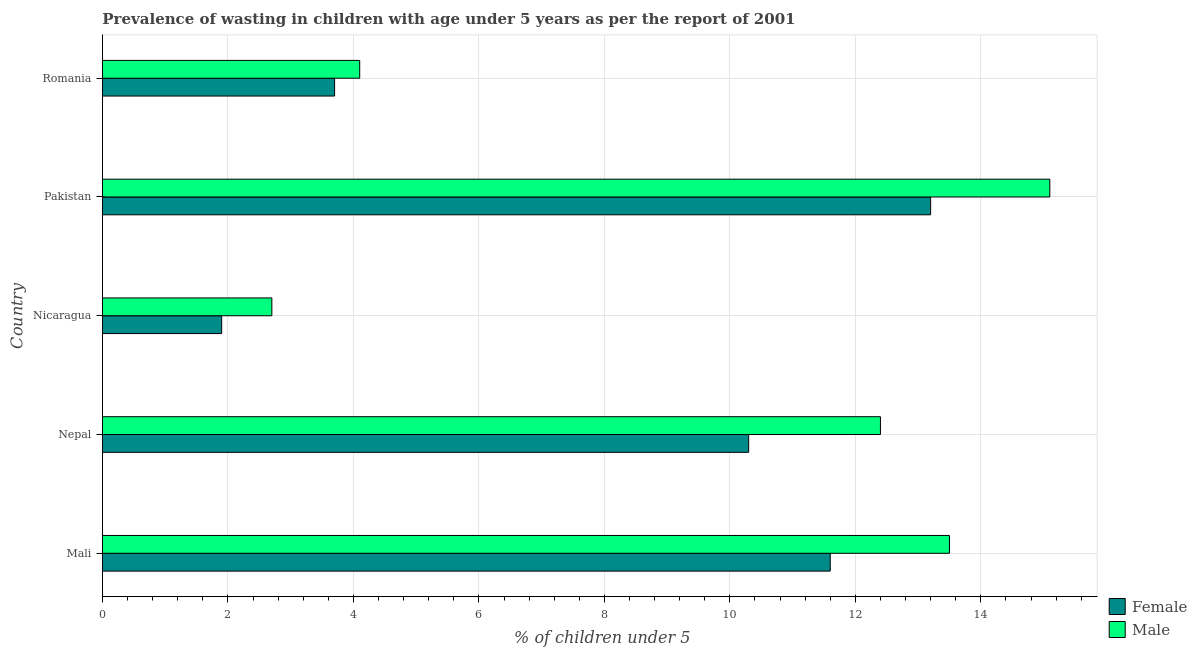Are the number of bars per tick equal to the number of legend labels?
Your answer should be compact. Yes. Are the number of bars on each tick of the Y-axis equal?
Offer a very short reply. Yes. How many bars are there on the 2nd tick from the top?
Provide a short and direct response. 2. How many bars are there on the 4th tick from the bottom?
Your response must be concise. 2. What is the label of the 5th group of bars from the top?
Give a very brief answer. Mali. In how many cases, is the number of bars for a given country not equal to the number of legend labels?
Your response must be concise. 0. What is the percentage of undernourished male children in Mali?
Your response must be concise. 13.5. Across all countries, what is the maximum percentage of undernourished male children?
Give a very brief answer. 15.1. Across all countries, what is the minimum percentage of undernourished male children?
Your answer should be compact. 2.7. In which country was the percentage of undernourished male children minimum?
Your answer should be very brief. Nicaragua. What is the total percentage of undernourished female children in the graph?
Give a very brief answer. 40.7. What is the difference between the percentage of undernourished male children in Nepal and that in Pakistan?
Ensure brevity in your answer.  -2.7. What is the difference between the percentage of undernourished male children in Mali and the percentage of undernourished female children in Romania?
Your answer should be compact. 9.8. What is the average percentage of undernourished male children per country?
Give a very brief answer. 9.56. What is the ratio of the percentage of undernourished female children in Mali to that in Nepal?
Provide a succinct answer. 1.13. Is the difference between the percentage of undernourished female children in Nepal and Nicaragua greater than the difference between the percentage of undernourished male children in Nepal and Nicaragua?
Offer a very short reply. No. What is the difference between the highest and the second highest percentage of undernourished male children?
Your answer should be compact. 1.6. Is the sum of the percentage of undernourished male children in Pakistan and Romania greater than the maximum percentage of undernourished female children across all countries?
Provide a succinct answer. Yes. What does the 1st bar from the bottom in Mali represents?
Ensure brevity in your answer.  Female. How many bars are there?
Give a very brief answer. 10. Are all the bars in the graph horizontal?
Provide a succinct answer. Yes. What is the difference between two consecutive major ticks on the X-axis?
Keep it short and to the point. 2. Does the graph contain grids?
Offer a very short reply. Yes. Where does the legend appear in the graph?
Give a very brief answer. Bottom right. What is the title of the graph?
Provide a short and direct response. Prevalence of wasting in children with age under 5 years as per the report of 2001. Does "Diarrhea" appear as one of the legend labels in the graph?
Keep it short and to the point. No. What is the label or title of the X-axis?
Your answer should be compact.  % of children under 5. What is the  % of children under 5 in Female in Mali?
Make the answer very short. 11.6. What is the  % of children under 5 of Female in Nepal?
Your answer should be very brief. 10.3. What is the  % of children under 5 in Male in Nepal?
Ensure brevity in your answer.  12.4. What is the  % of children under 5 in Female in Nicaragua?
Your answer should be compact. 1.9. What is the  % of children under 5 of Male in Nicaragua?
Your answer should be very brief. 2.7. What is the  % of children under 5 of Female in Pakistan?
Offer a very short reply. 13.2. What is the  % of children under 5 in Male in Pakistan?
Offer a very short reply. 15.1. What is the  % of children under 5 in Female in Romania?
Offer a terse response. 3.7. What is the  % of children under 5 in Male in Romania?
Keep it short and to the point. 4.1. Across all countries, what is the maximum  % of children under 5 in Female?
Provide a short and direct response. 13.2. Across all countries, what is the maximum  % of children under 5 of Male?
Offer a terse response. 15.1. Across all countries, what is the minimum  % of children under 5 in Female?
Make the answer very short. 1.9. Across all countries, what is the minimum  % of children under 5 in Male?
Offer a very short reply. 2.7. What is the total  % of children under 5 in Female in the graph?
Your answer should be compact. 40.7. What is the total  % of children under 5 of Male in the graph?
Offer a terse response. 47.8. What is the difference between the  % of children under 5 in Male in Mali and that in Nicaragua?
Provide a succinct answer. 10.8. What is the difference between the  % of children under 5 of Female in Mali and that in Pakistan?
Make the answer very short. -1.6. What is the difference between the  % of children under 5 of Male in Mali and that in Pakistan?
Keep it short and to the point. -1.6. What is the difference between the  % of children under 5 of Female in Mali and that in Romania?
Your answer should be very brief. 7.9. What is the difference between the  % of children under 5 of Female in Nepal and that in Nicaragua?
Offer a terse response. 8.4. What is the difference between the  % of children under 5 of Male in Nepal and that in Nicaragua?
Provide a succinct answer. 9.7. What is the difference between the  % of children under 5 of Male in Nepal and that in Pakistan?
Provide a short and direct response. -2.7. What is the difference between the  % of children under 5 in Male in Nepal and that in Romania?
Provide a succinct answer. 8.3. What is the difference between the  % of children under 5 of Female in Nicaragua and that in Pakistan?
Ensure brevity in your answer.  -11.3. What is the difference between the  % of children under 5 of Female in Nicaragua and that in Romania?
Your answer should be compact. -1.8. What is the difference between the  % of children under 5 of Male in Nicaragua and that in Romania?
Ensure brevity in your answer.  -1.4. What is the difference between the  % of children under 5 in Female in Mali and the  % of children under 5 in Male in Nicaragua?
Your answer should be compact. 8.9. What is the difference between the  % of children under 5 in Female in Mali and the  % of children under 5 in Male in Romania?
Ensure brevity in your answer.  7.5. What is the difference between the  % of children under 5 in Female in Nepal and the  % of children under 5 in Male in Nicaragua?
Give a very brief answer. 7.6. What is the difference between the  % of children under 5 in Female in Nepal and the  % of children under 5 in Male in Pakistan?
Offer a terse response. -4.8. What is the difference between the  % of children under 5 of Female in Nicaragua and the  % of children under 5 of Male in Romania?
Your response must be concise. -2.2. What is the difference between the  % of children under 5 of Female in Pakistan and the  % of children under 5 of Male in Romania?
Provide a succinct answer. 9.1. What is the average  % of children under 5 of Female per country?
Offer a very short reply. 8.14. What is the average  % of children under 5 in Male per country?
Keep it short and to the point. 9.56. What is the difference between the  % of children under 5 of Female and  % of children under 5 of Male in Nicaragua?
Ensure brevity in your answer.  -0.8. What is the difference between the  % of children under 5 in Female and  % of children under 5 in Male in Pakistan?
Provide a short and direct response. -1.9. What is the ratio of the  % of children under 5 of Female in Mali to that in Nepal?
Your response must be concise. 1.13. What is the ratio of the  % of children under 5 of Male in Mali to that in Nepal?
Provide a succinct answer. 1.09. What is the ratio of the  % of children under 5 in Female in Mali to that in Nicaragua?
Ensure brevity in your answer.  6.11. What is the ratio of the  % of children under 5 of Female in Mali to that in Pakistan?
Your answer should be very brief. 0.88. What is the ratio of the  % of children under 5 in Male in Mali to that in Pakistan?
Offer a terse response. 0.89. What is the ratio of the  % of children under 5 in Female in Mali to that in Romania?
Your answer should be very brief. 3.14. What is the ratio of the  % of children under 5 in Male in Mali to that in Romania?
Give a very brief answer. 3.29. What is the ratio of the  % of children under 5 in Female in Nepal to that in Nicaragua?
Your answer should be very brief. 5.42. What is the ratio of the  % of children under 5 of Male in Nepal to that in Nicaragua?
Keep it short and to the point. 4.59. What is the ratio of the  % of children under 5 of Female in Nepal to that in Pakistan?
Ensure brevity in your answer.  0.78. What is the ratio of the  % of children under 5 in Male in Nepal to that in Pakistan?
Offer a terse response. 0.82. What is the ratio of the  % of children under 5 of Female in Nepal to that in Romania?
Offer a terse response. 2.78. What is the ratio of the  % of children under 5 in Male in Nepal to that in Romania?
Your response must be concise. 3.02. What is the ratio of the  % of children under 5 of Female in Nicaragua to that in Pakistan?
Your answer should be very brief. 0.14. What is the ratio of the  % of children under 5 in Male in Nicaragua to that in Pakistan?
Give a very brief answer. 0.18. What is the ratio of the  % of children under 5 in Female in Nicaragua to that in Romania?
Your response must be concise. 0.51. What is the ratio of the  % of children under 5 in Male in Nicaragua to that in Romania?
Provide a short and direct response. 0.66. What is the ratio of the  % of children under 5 of Female in Pakistan to that in Romania?
Offer a terse response. 3.57. What is the ratio of the  % of children under 5 of Male in Pakistan to that in Romania?
Your answer should be very brief. 3.68. What is the difference between the highest and the lowest  % of children under 5 in Female?
Provide a short and direct response. 11.3. 